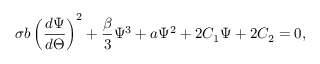Convert formula to latex. <formula><loc_0><loc_0><loc_500><loc_500>\sigma b \left ( \frac { d \Psi } { d \Theta } \right ) ^ { 2 } + \frac { \beta } { 3 } \Psi ^ { 3 } + a \Psi ^ { 2 } + 2 C _ { 1 } \Psi + 2 C _ { 2 } = 0 ,</formula> 